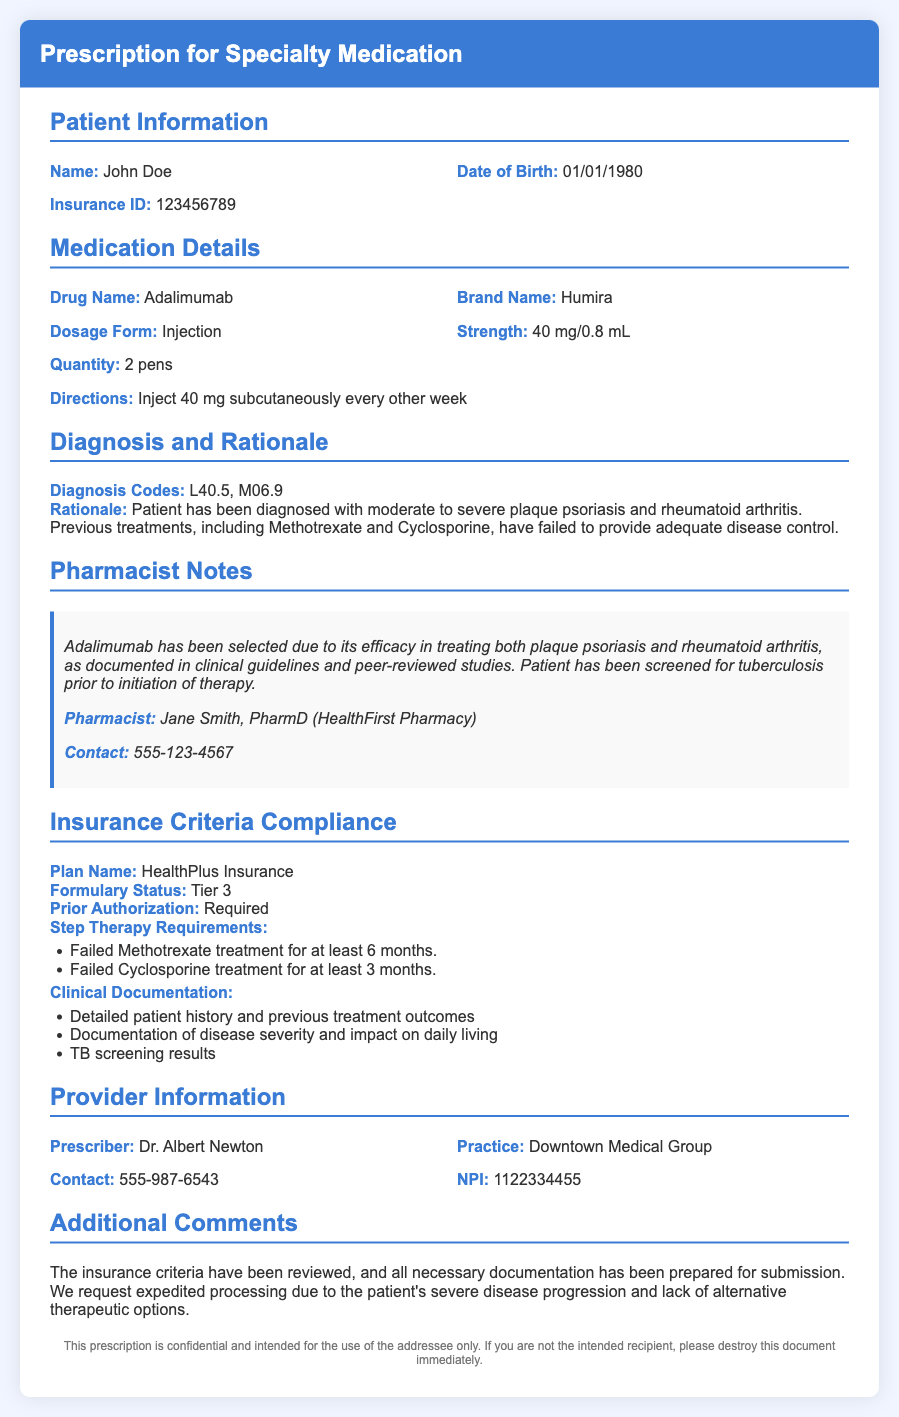What is the patient's name? The patient's name is explicitly stated in the document.
Answer: John Doe What is the drug name prescribed? The drug name is provided in the medication details section.
Answer: Adalimumab What is the dosage form of the medication? The dosage form is listed in the medication details section.
Answer: Injection What diagnosis codes are mentioned? The diagnosis codes are stated under the diagnosis and rationale section.
Answer: L40.5, M06.9 Who is the pharmacist? The pharmacist's name is noted in the pharmacist notes section.
Answer: Jane Smith, PharmD What is the formulary status of the medication? The formulary status is provided under insurance criteria compliance.
Answer: Tier 3 What is the patient's insurance ID? The patient's insurance ID is stated in the patient information section.
Answer: 123456789 What is the prescribed strength of the medication? The strength of the medication is detailed in the medication details section.
Answer: 40 mg/0.8 mL What are the step therapy requirements? The step therapy requirements are listed in the insurance criteria compliance section.
Answer: Failed Methotrexate treatment for at least 6 months; Failed Cyclosporine treatment for at least 3 months What is the prescriber's NPI number? The prescriber's NPI number is specified in the provider information section.
Answer: 1122334455 